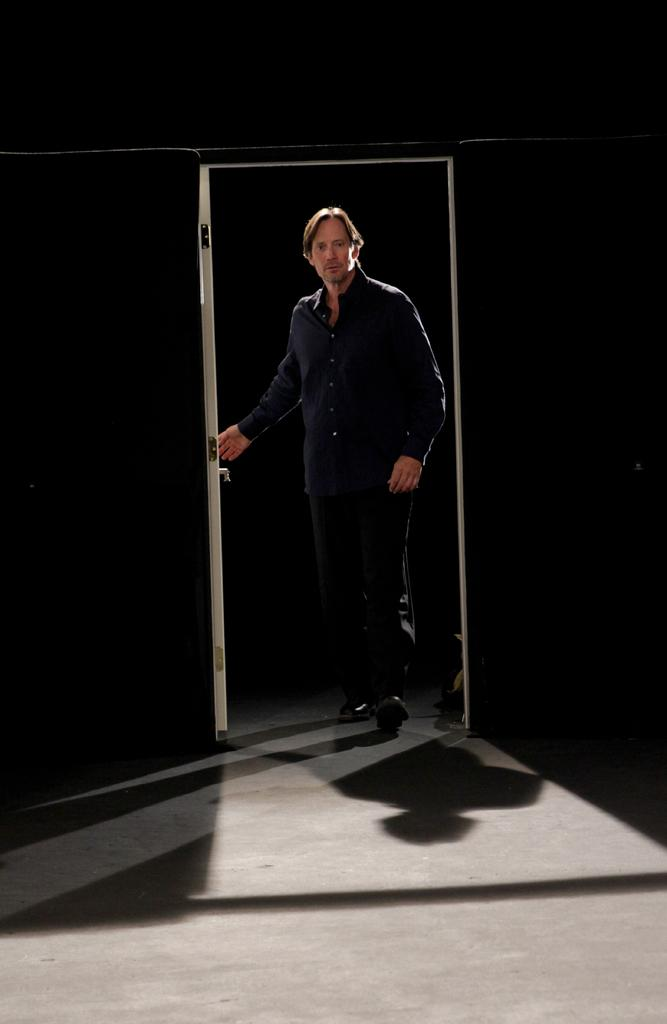What is the main subject of the image? There is a man standing in the image. Where is the man standing? The man is standing on the ground. What structures can be seen in the image? There is a door and a wall in the image. How would you describe the lighting in the image? The background of the image is dark. Can you tell me how many snails are crawling on the toothpaste in the image? There is no toothpaste or snails present in the image. 